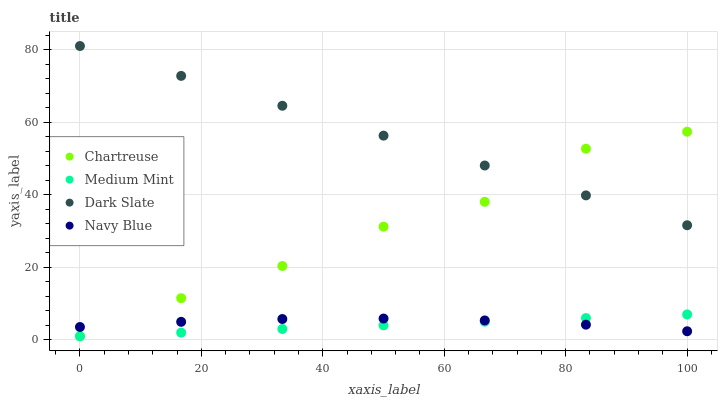Does Medium Mint have the minimum area under the curve?
Answer yes or no. Yes. Does Dark Slate have the maximum area under the curve?
Answer yes or no. Yes. Does Chartreuse have the minimum area under the curve?
Answer yes or no. No. Does Chartreuse have the maximum area under the curve?
Answer yes or no. No. Is Medium Mint the smoothest?
Answer yes or no. Yes. Is Chartreuse the roughest?
Answer yes or no. Yes. Is Dark Slate the smoothest?
Answer yes or no. No. Is Dark Slate the roughest?
Answer yes or no. No. Does Medium Mint have the lowest value?
Answer yes or no. Yes. Does Dark Slate have the lowest value?
Answer yes or no. No. Does Dark Slate have the highest value?
Answer yes or no. Yes. Does Chartreuse have the highest value?
Answer yes or no. No. Is Navy Blue less than Dark Slate?
Answer yes or no. Yes. Is Dark Slate greater than Navy Blue?
Answer yes or no. Yes. Does Chartreuse intersect Dark Slate?
Answer yes or no. Yes. Is Chartreuse less than Dark Slate?
Answer yes or no. No. Is Chartreuse greater than Dark Slate?
Answer yes or no. No. Does Navy Blue intersect Dark Slate?
Answer yes or no. No. 